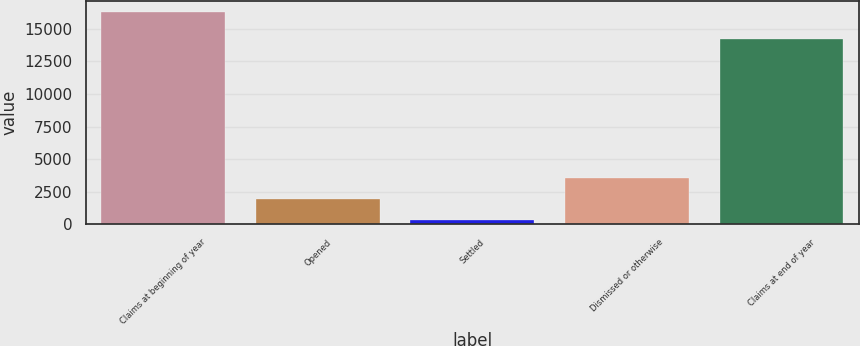Convert chart to OTSL. <chart><loc_0><loc_0><loc_500><loc_500><bar_chart><fcel>Claims at beginning of year<fcel>Opened<fcel>Settled<fcel>Dismissed or otherwise<fcel>Claims at end of year<nl><fcel>16320<fcel>1928.1<fcel>329<fcel>3527.2<fcel>14215<nl></chart> 